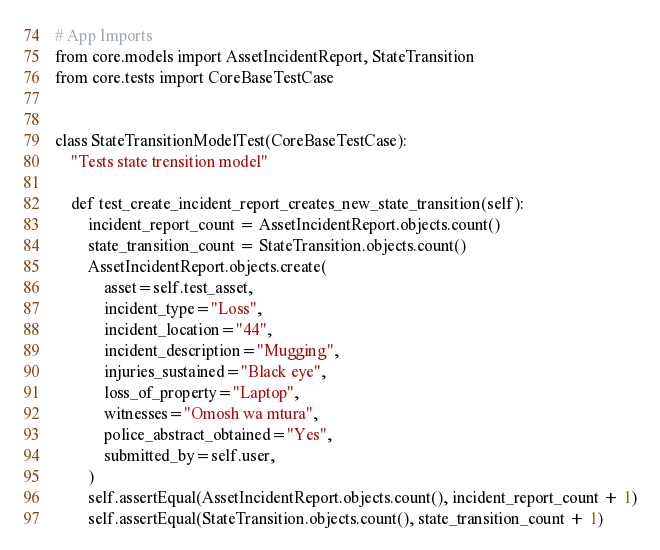<code> <loc_0><loc_0><loc_500><loc_500><_Python_># App Imports
from core.models import AssetIncidentReport, StateTransition
from core.tests import CoreBaseTestCase


class StateTransitionModelTest(CoreBaseTestCase):
    "Tests state trensition model"

    def test_create_incident_report_creates_new_state_transition(self):
        incident_report_count = AssetIncidentReport.objects.count()
        state_transition_count = StateTransition.objects.count()
        AssetIncidentReport.objects.create(
            asset=self.test_asset,
            incident_type="Loss",
            incident_location="44",
            incident_description="Mugging",
            injuries_sustained="Black eye",
            loss_of_property="Laptop",
            witnesses="Omosh wa mtura",
            police_abstract_obtained="Yes",
            submitted_by=self.user,
        )
        self.assertEqual(AssetIncidentReport.objects.count(), incident_report_count + 1)
        self.assertEqual(StateTransition.objects.count(), state_transition_count + 1)
</code> 